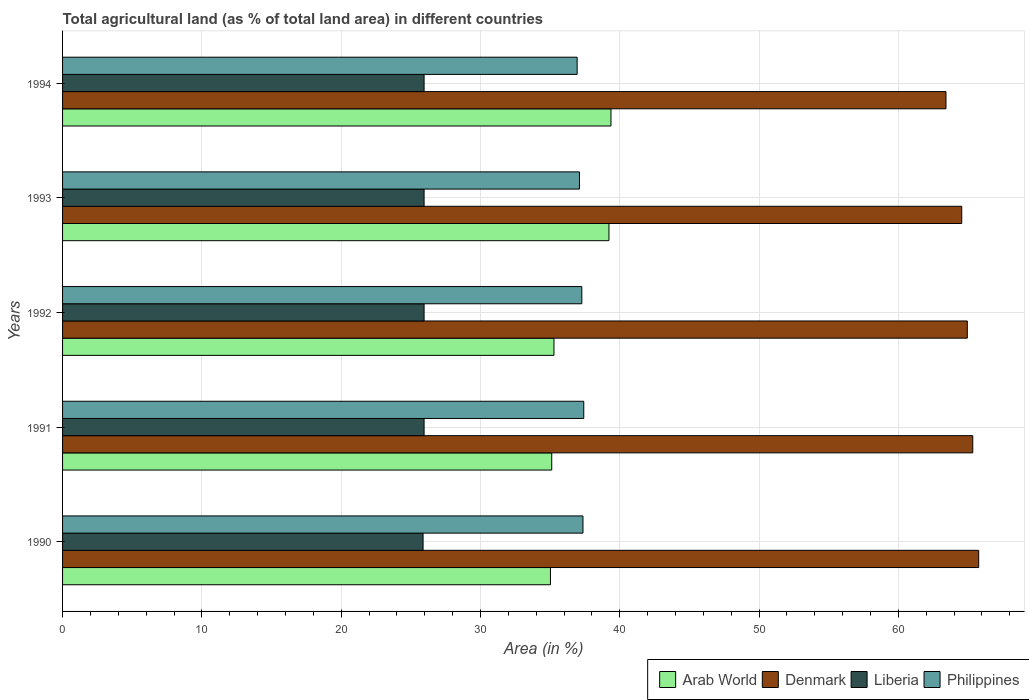How many different coloured bars are there?
Keep it short and to the point. 4. How many groups of bars are there?
Keep it short and to the point. 5. Are the number of bars per tick equal to the number of legend labels?
Offer a terse response. Yes. Are the number of bars on each tick of the Y-axis equal?
Your response must be concise. Yes. How many bars are there on the 3rd tick from the top?
Offer a terse response. 4. How many bars are there on the 4th tick from the bottom?
Ensure brevity in your answer.  4. What is the percentage of agricultural land in Arab World in 1993?
Provide a short and direct response. 39.23. Across all years, what is the maximum percentage of agricultural land in Liberia?
Provide a short and direct response. 25.96. Across all years, what is the minimum percentage of agricultural land in Philippines?
Provide a succinct answer. 36.94. In which year was the percentage of agricultural land in Denmark minimum?
Make the answer very short. 1994. What is the total percentage of agricultural land in Liberia in the graph?
Ensure brevity in your answer.  129.7. What is the difference between the percentage of agricultural land in Liberia in 1992 and that in 1994?
Your answer should be compact. 0. What is the difference between the percentage of agricultural land in Arab World in 1994 and the percentage of agricultural land in Liberia in 1991?
Provide a succinct answer. 13.42. What is the average percentage of agricultural land in Liberia per year?
Keep it short and to the point. 25.94. In the year 1993, what is the difference between the percentage of agricultural land in Arab World and percentage of agricultural land in Denmark?
Give a very brief answer. -25.33. In how many years, is the percentage of agricultural land in Denmark greater than 26 %?
Offer a terse response. 5. What is the ratio of the percentage of agricultural land in Denmark in 1993 to that in 1994?
Your response must be concise. 1.02. Is the percentage of agricultural land in Liberia in 1991 less than that in 1993?
Your response must be concise. No. What is the difference between the highest and the second highest percentage of agricultural land in Arab World?
Ensure brevity in your answer.  0.14. What is the difference between the highest and the lowest percentage of agricultural land in Liberia?
Your answer should be compact. 0.07. Is it the case that in every year, the sum of the percentage of agricultural land in Arab World and percentage of agricultural land in Liberia is greater than the sum of percentage of agricultural land in Philippines and percentage of agricultural land in Denmark?
Offer a terse response. No. What does the 1st bar from the top in 1992 represents?
Offer a very short reply. Philippines. What does the 2nd bar from the bottom in 1990 represents?
Your response must be concise. Denmark. How many bars are there?
Ensure brevity in your answer.  20. Are all the bars in the graph horizontal?
Offer a terse response. Yes. Does the graph contain any zero values?
Your answer should be very brief. No. Where does the legend appear in the graph?
Your answer should be compact. Bottom right. How are the legend labels stacked?
Make the answer very short. Horizontal. What is the title of the graph?
Provide a short and direct response. Total agricultural land (as % of total land area) in different countries. Does "Russian Federation" appear as one of the legend labels in the graph?
Keep it short and to the point. No. What is the label or title of the X-axis?
Provide a succinct answer. Area (in %). What is the Area (in %) of Arab World in 1990?
Offer a terse response. 35.03. What is the Area (in %) in Denmark in 1990?
Offer a very short reply. 65.77. What is the Area (in %) of Liberia in 1990?
Give a very brief answer. 25.88. What is the Area (in %) of Philippines in 1990?
Your answer should be very brief. 37.36. What is the Area (in %) of Arab World in 1991?
Your answer should be compact. 35.12. What is the Area (in %) in Denmark in 1991?
Provide a short and direct response. 65.35. What is the Area (in %) of Liberia in 1991?
Provide a succinct answer. 25.96. What is the Area (in %) of Philippines in 1991?
Offer a very short reply. 37.42. What is the Area (in %) of Arab World in 1992?
Provide a short and direct response. 35.28. What is the Area (in %) of Denmark in 1992?
Give a very brief answer. 64.95. What is the Area (in %) in Liberia in 1992?
Keep it short and to the point. 25.96. What is the Area (in %) of Philippines in 1992?
Make the answer very short. 37.28. What is the Area (in %) of Arab World in 1993?
Give a very brief answer. 39.23. What is the Area (in %) of Denmark in 1993?
Offer a very short reply. 64.55. What is the Area (in %) in Liberia in 1993?
Keep it short and to the point. 25.96. What is the Area (in %) of Philippines in 1993?
Keep it short and to the point. 37.11. What is the Area (in %) of Arab World in 1994?
Keep it short and to the point. 39.37. What is the Area (in %) of Denmark in 1994?
Provide a succinct answer. 63.42. What is the Area (in %) of Liberia in 1994?
Keep it short and to the point. 25.96. What is the Area (in %) of Philippines in 1994?
Keep it short and to the point. 36.94. Across all years, what is the maximum Area (in %) in Arab World?
Provide a succinct answer. 39.37. Across all years, what is the maximum Area (in %) of Denmark?
Provide a short and direct response. 65.77. Across all years, what is the maximum Area (in %) of Liberia?
Provide a succinct answer. 25.96. Across all years, what is the maximum Area (in %) of Philippines?
Make the answer very short. 37.42. Across all years, what is the minimum Area (in %) in Arab World?
Provide a short and direct response. 35.03. Across all years, what is the minimum Area (in %) of Denmark?
Offer a terse response. 63.42. Across all years, what is the minimum Area (in %) of Liberia?
Your answer should be very brief. 25.88. Across all years, what is the minimum Area (in %) in Philippines?
Give a very brief answer. 36.94. What is the total Area (in %) of Arab World in the graph?
Your answer should be compact. 184.02. What is the total Area (in %) in Denmark in the graph?
Offer a very short reply. 324.05. What is the total Area (in %) in Liberia in the graph?
Provide a succinct answer. 129.7. What is the total Area (in %) in Philippines in the graph?
Your answer should be very brief. 186.11. What is the difference between the Area (in %) in Arab World in 1990 and that in 1991?
Give a very brief answer. -0.09. What is the difference between the Area (in %) of Denmark in 1990 and that in 1991?
Make the answer very short. 0.42. What is the difference between the Area (in %) in Liberia in 1990 and that in 1991?
Provide a short and direct response. -0.07. What is the difference between the Area (in %) in Philippines in 1990 and that in 1991?
Ensure brevity in your answer.  -0.06. What is the difference between the Area (in %) in Arab World in 1990 and that in 1992?
Provide a succinct answer. -0.25. What is the difference between the Area (in %) in Denmark in 1990 and that in 1992?
Your answer should be compact. 0.82. What is the difference between the Area (in %) of Liberia in 1990 and that in 1992?
Make the answer very short. -0.07. What is the difference between the Area (in %) in Philippines in 1990 and that in 1992?
Provide a short and direct response. 0.08. What is the difference between the Area (in %) in Arab World in 1990 and that in 1993?
Keep it short and to the point. -4.2. What is the difference between the Area (in %) of Denmark in 1990 and that in 1993?
Give a very brief answer. 1.22. What is the difference between the Area (in %) in Liberia in 1990 and that in 1993?
Ensure brevity in your answer.  -0.07. What is the difference between the Area (in %) of Philippines in 1990 and that in 1993?
Give a very brief answer. 0.25. What is the difference between the Area (in %) in Arab World in 1990 and that in 1994?
Your response must be concise. -4.34. What is the difference between the Area (in %) of Denmark in 1990 and that in 1994?
Provide a succinct answer. 2.35. What is the difference between the Area (in %) of Liberia in 1990 and that in 1994?
Offer a terse response. -0.07. What is the difference between the Area (in %) of Philippines in 1990 and that in 1994?
Offer a very short reply. 0.42. What is the difference between the Area (in %) of Arab World in 1991 and that in 1992?
Ensure brevity in your answer.  -0.16. What is the difference between the Area (in %) in Denmark in 1991 and that in 1992?
Make the answer very short. 0.39. What is the difference between the Area (in %) in Philippines in 1991 and that in 1992?
Ensure brevity in your answer.  0.14. What is the difference between the Area (in %) in Arab World in 1991 and that in 1993?
Keep it short and to the point. -4.11. What is the difference between the Area (in %) in Denmark in 1991 and that in 1993?
Ensure brevity in your answer.  0.79. What is the difference between the Area (in %) in Liberia in 1991 and that in 1993?
Offer a very short reply. 0. What is the difference between the Area (in %) in Philippines in 1991 and that in 1993?
Your answer should be compact. 0.31. What is the difference between the Area (in %) in Arab World in 1991 and that in 1994?
Keep it short and to the point. -4.25. What is the difference between the Area (in %) in Denmark in 1991 and that in 1994?
Your answer should be compact. 1.92. What is the difference between the Area (in %) in Philippines in 1991 and that in 1994?
Provide a short and direct response. 0.48. What is the difference between the Area (in %) in Arab World in 1992 and that in 1993?
Keep it short and to the point. -3.95. What is the difference between the Area (in %) in Denmark in 1992 and that in 1993?
Your response must be concise. 0.4. What is the difference between the Area (in %) in Liberia in 1992 and that in 1993?
Keep it short and to the point. 0. What is the difference between the Area (in %) in Philippines in 1992 and that in 1993?
Make the answer very short. 0.17. What is the difference between the Area (in %) in Arab World in 1992 and that in 1994?
Provide a short and direct response. -4.09. What is the difference between the Area (in %) of Denmark in 1992 and that in 1994?
Provide a succinct answer. 1.53. What is the difference between the Area (in %) of Liberia in 1992 and that in 1994?
Provide a short and direct response. 0. What is the difference between the Area (in %) of Philippines in 1992 and that in 1994?
Offer a very short reply. 0.34. What is the difference between the Area (in %) of Arab World in 1993 and that in 1994?
Provide a succinct answer. -0.14. What is the difference between the Area (in %) of Denmark in 1993 and that in 1994?
Make the answer very short. 1.13. What is the difference between the Area (in %) in Philippines in 1993 and that in 1994?
Provide a short and direct response. 0.17. What is the difference between the Area (in %) of Arab World in 1990 and the Area (in %) of Denmark in 1991?
Ensure brevity in your answer.  -30.32. What is the difference between the Area (in %) in Arab World in 1990 and the Area (in %) in Liberia in 1991?
Make the answer very short. 9.07. What is the difference between the Area (in %) of Arab World in 1990 and the Area (in %) of Philippines in 1991?
Make the answer very short. -2.39. What is the difference between the Area (in %) in Denmark in 1990 and the Area (in %) in Liberia in 1991?
Your answer should be compact. 39.82. What is the difference between the Area (in %) in Denmark in 1990 and the Area (in %) in Philippines in 1991?
Your answer should be very brief. 28.35. What is the difference between the Area (in %) of Liberia in 1990 and the Area (in %) of Philippines in 1991?
Your response must be concise. -11.54. What is the difference between the Area (in %) of Arab World in 1990 and the Area (in %) of Denmark in 1992?
Give a very brief answer. -29.93. What is the difference between the Area (in %) in Arab World in 1990 and the Area (in %) in Liberia in 1992?
Your response must be concise. 9.07. What is the difference between the Area (in %) of Arab World in 1990 and the Area (in %) of Philippines in 1992?
Provide a succinct answer. -2.25. What is the difference between the Area (in %) in Denmark in 1990 and the Area (in %) in Liberia in 1992?
Ensure brevity in your answer.  39.82. What is the difference between the Area (in %) in Denmark in 1990 and the Area (in %) in Philippines in 1992?
Your response must be concise. 28.49. What is the difference between the Area (in %) of Liberia in 1990 and the Area (in %) of Philippines in 1992?
Your answer should be compact. -11.39. What is the difference between the Area (in %) of Arab World in 1990 and the Area (in %) of Denmark in 1993?
Provide a succinct answer. -29.53. What is the difference between the Area (in %) in Arab World in 1990 and the Area (in %) in Liberia in 1993?
Ensure brevity in your answer.  9.07. What is the difference between the Area (in %) in Arab World in 1990 and the Area (in %) in Philippines in 1993?
Your answer should be compact. -2.08. What is the difference between the Area (in %) in Denmark in 1990 and the Area (in %) in Liberia in 1993?
Your answer should be compact. 39.82. What is the difference between the Area (in %) in Denmark in 1990 and the Area (in %) in Philippines in 1993?
Provide a short and direct response. 28.66. What is the difference between the Area (in %) of Liberia in 1990 and the Area (in %) of Philippines in 1993?
Make the answer very short. -11.23. What is the difference between the Area (in %) of Arab World in 1990 and the Area (in %) of Denmark in 1994?
Provide a succinct answer. -28.39. What is the difference between the Area (in %) in Arab World in 1990 and the Area (in %) in Liberia in 1994?
Make the answer very short. 9.07. What is the difference between the Area (in %) in Arab World in 1990 and the Area (in %) in Philippines in 1994?
Give a very brief answer. -1.91. What is the difference between the Area (in %) of Denmark in 1990 and the Area (in %) of Liberia in 1994?
Make the answer very short. 39.82. What is the difference between the Area (in %) in Denmark in 1990 and the Area (in %) in Philippines in 1994?
Provide a short and direct response. 28.83. What is the difference between the Area (in %) in Liberia in 1990 and the Area (in %) in Philippines in 1994?
Keep it short and to the point. -11.06. What is the difference between the Area (in %) in Arab World in 1991 and the Area (in %) in Denmark in 1992?
Make the answer very short. -29.84. What is the difference between the Area (in %) in Arab World in 1991 and the Area (in %) in Liberia in 1992?
Provide a succinct answer. 9.16. What is the difference between the Area (in %) of Arab World in 1991 and the Area (in %) of Philippines in 1992?
Your answer should be very brief. -2.16. What is the difference between the Area (in %) in Denmark in 1991 and the Area (in %) in Liberia in 1992?
Make the answer very short. 39.39. What is the difference between the Area (in %) of Denmark in 1991 and the Area (in %) of Philippines in 1992?
Your answer should be compact. 28.07. What is the difference between the Area (in %) of Liberia in 1991 and the Area (in %) of Philippines in 1992?
Ensure brevity in your answer.  -11.32. What is the difference between the Area (in %) of Arab World in 1991 and the Area (in %) of Denmark in 1993?
Provide a short and direct response. -29.44. What is the difference between the Area (in %) in Arab World in 1991 and the Area (in %) in Liberia in 1993?
Your response must be concise. 9.16. What is the difference between the Area (in %) in Arab World in 1991 and the Area (in %) in Philippines in 1993?
Keep it short and to the point. -1.99. What is the difference between the Area (in %) of Denmark in 1991 and the Area (in %) of Liberia in 1993?
Keep it short and to the point. 39.39. What is the difference between the Area (in %) in Denmark in 1991 and the Area (in %) in Philippines in 1993?
Your answer should be compact. 28.24. What is the difference between the Area (in %) in Liberia in 1991 and the Area (in %) in Philippines in 1993?
Make the answer very short. -11.15. What is the difference between the Area (in %) in Arab World in 1991 and the Area (in %) in Denmark in 1994?
Keep it short and to the point. -28.3. What is the difference between the Area (in %) of Arab World in 1991 and the Area (in %) of Liberia in 1994?
Offer a terse response. 9.16. What is the difference between the Area (in %) in Arab World in 1991 and the Area (in %) in Philippines in 1994?
Offer a terse response. -1.82. What is the difference between the Area (in %) of Denmark in 1991 and the Area (in %) of Liberia in 1994?
Provide a succinct answer. 39.39. What is the difference between the Area (in %) of Denmark in 1991 and the Area (in %) of Philippines in 1994?
Give a very brief answer. 28.4. What is the difference between the Area (in %) in Liberia in 1991 and the Area (in %) in Philippines in 1994?
Keep it short and to the point. -10.99. What is the difference between the Area (in %) of Arab World in 1992 and the Area (in %) of Denmark in 1993?
Keep it short and to the point. -29.27. What is the difference between the Area (in %) in Arab World in 1992 and the Area (in %) in Liberia in 1993?
Keep it short and to the point. 9.32. What is the difference between the Area (in %) of Arab World in 1992 and the Area (in %) of Philippines in 1993?
Ensure brevity in your answer.  -1.83. What is the difference between the Area (in %) in Denmark in 1992 and the Area (in %) in Liberia in 1993?
Keep it short and to the point. 39. What is the difference between the Area (in %) of Denmark in 1992 and the Area (in %) of Philippines in 1993?
Offer a very short reply. 27.84. What is the difference between the Area (in %) of Liberia in 1992 and the Area (in %) of Philippines in 1993?
Your answer should be compact. -11.15. What is the difference between the Area (in %) of Arab World in 1992 and the Area (in %) of Denmark in 1994?
Provide a succinct answer. -28.14. What is the difference between the Area (in %) in Arab World in 1992 and the Area (in %) in Liberia in 1994?
Provide a succinct answer. 9.32. What is the difference between the Area (in %) of Arab World in 1992 and the Area (in %) of Philippines in 1994?
Provide a short and direct response. -1.66. What is the difference between the Area (in %) in Denmark in 1992 and the Area (in %) in Liberia in 1994?
Your answer should be compact. 39. What is the difference between the Area (in %) of Denmark in 1992 and the Area (in %) of Philippines in 1994?
Give a very brief answer. 28.01. What is the difference between the Area (in %) of Liberia in 1992 and the Area (in %) of Philippines in 1994?
Give a very brief answer. -10.99. What is the difference between the Area (in %) of Arab World in 1993 and the Area (in %) of Denmark in 1994?
Keep it short and to the point. -24.2. What is the difference between the Area (in %) in Arab World in 1993 and the Area (in %) in Liberia in 1994?
Ensure brevity in your answer.  13.27. What is the difference between the Area (in %) of Arab World in 1993 and the Area (in %) of Philippines in 1994?
Offer a terse response. 2.28. What is the difference between the Area (in %) of Denmark in 1993 and the Area (in %) of Liberia in 1994?
Ensure brevity in your answer.  38.6. What is the difference between the Area (in %) in Denmark in 1993 and the Area (in %) in Philippines in 1994?
Ensure brevity in your answer.  27.61. What is the difference between the Area (in %) of Liberia in 1993 and the Area (in %) of Philippines in 1994?
Offer a very short reply. -10.99. What is the average Area (in %) of Arab World per year?
Ensure brevity in your answer.  36.8. What is the average Area (in %) in Denmark per year?
Offer a very short reply. 64.81. What is the average Area (in %) in Liberia per year?
Make the answer very short. 25.94. What is the average Area (in %) of Philippines per year?
Ensure brevity in your answer.  37.22. In the year 1990, what is the difference between the Area (in %) in Arab World and Area (in %) in Denmark?
Keep it short and to the point. -30.74. In the year 1990, what is the difference between the Area (in %) in Arab World and Area (in %) in Liberia?
Provide a short and direct response. 9.14. In the year 1990, what is the difference between the Area (in %) of Arab World and Area (in %) of Philippines?
Ensure brevity in your answer.  -2.33. In the year 1990, what is the difference between the Area (in %) in Denmark and Area (in %) in Liberia?
Ensure brevity in your answer.  39.89. In the year 1990, what is the difference between the Area (in %) in Denmark and Area (in %) in Philippines?
Give a very brief answer. 28.41. In the year 1990, what is the difference between the Area (in %) of Liberia and Area (in %) of Philippines?
Give a very brief answer. -11.48. In the year 1991, what is the difference between the Area (in %) of Arab World and Area (in %) of Denmark?
Ensure brevity in your answer.  -30.23. In the year 1991, what is the difference between the Area (in %) in Arab World and Area (in %) in Liberia?
Ensure brevity in your answer.  9.16. In the year 1991, what is the difference between the Area (in %) in Arab World and Area (in %) in Philippines?
Keep it short and to the point. -2.3. In the year 1991, what is the difference between the Area (in %) in Denmark and Area (in %) in Liberia?
Your answer should be compact. 39.39. In the year 1991, what is the difference between the Area (in %) of Denmark and Area (in %) of Philippines?
Provide a short and direct response. 27.93. In the year 1991, what is the difference between the Area (in %) in Liberia and Area (in %) in Philippines?
Ensure brevity in your answer.  -11.46. In the year 1992, what is the difference between the Area (in %) of Arab World and Area (in %) of Denmark?
Your answer should be compact. -29.68. In the year 1992, what is the difference between the Area (in %) in Arab World and Area (in %) in Liberia?
Ensure brevity in your answer.  9.32. In the year 1992, what is the difference between the Area (in %) in Arab World and Area (in %) in Philippines?
Make the answer very short. -2. In the year 1992, what is the difference between the Area (in %) of Denmark and Area (in %) of Liberia?
Provide a short and direct response. 39. In the year 1992, what is the difference between the Area (in %) of Denmark and Area (in %) of Philippines?
Your answer should be very brief. 27.68. In the year 1992, what is the difference between the Area (in %) in Liberia and Area (in %) in Philippines?
Provide a short and direct response. -11.32. In the year 1993, what is the difference between the Area (in %) of Arab World and Area (in %) of Denmark?
Offer a terse response. -25.33. In the year 1993, what is the difference between the Area (in %) in Arab World and Area (in %) in Liberia?
Offer a very short reply. 13.27. In the year 1993, what is the difference between the Area (in %) of Arab World and Area (in %) of Philippines?
Provide a short and direct response. 2.12. In the year 1993, what is the difference between the Area (in %) in Denmark and Area (in %) in Liberia?
Ensure brevity in your answer.  38.6. In the year 1993, what is the difference between the Area (in %) of Denmark and Area (in %) of Philippines?
Offer a very short reply. 27.44. In the year 1993, what is the difference between the Area (in %) in Liberia and Area (in %) in Philippines?
Your response must be concise. -11.15. In the year 1994, what is the difference between the Area (in %) of Arab World and Area (in %) of Denmark?
Make the answer very short. -24.05. In the year 1994, what is the difference between the Area (in %) of Arab World and Area (in %) of Liberia?
Keep it short and to the point. 13.42. In the year 1994, what is the difference between the Area (in %) of Arab World and Area (in %) of Philippines?
Your answer should be compact. 2.43. In the year 1994, what is the difference between the Area (in %) in Denmark and Area (in %) in Liberia?
Your answer should be compact. 37.47. In the year 1994, what is the difference between the Area (in %) in Denmark and Area (in %) in Philippines?
Give a very brief answer. 26.48. In the year 1994, what is the difference between the Area (in %) in Liberia and Area (in %) in Philippines?
Your response must be concise. -10.99. What is the ratio of the Area (in %) of Denmark in 1990 to that in 1991?
Offer a very short reply. 1.01. What is the ratio of the Area (in %) of Liberia in 1990 to that in 1991?
Your response must be concise. 1. What is the ratio of the Area (in %) of Denmark in 1990 to that in 1992?
Give a very brief answer. 1.01. What is the ratio of the Area (in %) in Philippines in 1990 to that in 1992?
Offer a very short reply. 1. What is the ratio of the Area (in %) of Arab World in 1990 to that in 1993?
Your answer should be compact. 0.89. What is the ratio of the Area (in %) in Denmark in 1990 to that in 1993?
Provide a succinct answer. 1.02. What is the ratio of the Area (in %) in Philippines in 1990 to that in 1993?
Your response must be concise. 1.01. What is the ratio of the Area (in %) in Arab World in 1990 to that in 1994?
Provide a succinct answer. 0.89. What is the ratio of the Area (in %) in Liberia in 1990 to that in 1994?
Your answer should be compact. 1. What is the ratio of the Area (in %) in Philippines in 1990 to that in 1994?
Provide a succinct answer. 1.01. What is the ratio of the Area (in %) in Denmark in 1991 to that in 1992?
Give a very brief answer. 1.01. What is the ratio of the Area (in %) of Arab World in 1991 to that in 1993?
Your answer should be very brief. 0.9. What is the ratio of the Area (in %) in Denmark in 1991 to that in 1993?
Offer a terse response. 1.01. What is the ratio of the Area (in %) of Liberia in 1991 to that in 1993?
Make the answer very short. 1. What is the ratio of the Area (in %) of Philippines in 1991 to that in 1993?
Give a very brief answer. 1.01. What is the ratio of the Area (in %) in Arab World in 1991 to that in 1994?
Provide a short and direct response. 0.89. What is the ratio of the Area (in %) of Denmark in 1991 to that in 1994?
Your answer should be compact. 1.03. What is the ratio of the Area (in %) of Liberia in 1991 to that in 1994?
Keep it short and to the point. 1. What is the ratio of the Area (in %) of Philippines in 1991 to that in 1994?
Provide a short and direct response. 1.01. What is the ratio of the Area (in %) in Arab World in 1992 to that in 1993?
Offer a terse response. 0.9. What is the ratio of the Area (in %) in Philippines in 1992 to that in 1993?
Make the answer very short. 1. What is the ratio of the Area (in %) in Arab World in 1992 to that in 1994?
Provide a short and direct response. 0.9. What is the ratio of the Area (in %) of Denmark in 1992 to that in 1994?
Make the answer very short. 1.02. What is the ratio of the Area (in %) of Philippines in 1992 to that in 1994?
Provide a succinct answer. 1.01. What is the ratio of the Area (in %) in Denmark in 1993 to that in 1994?
Your response must be concise. 1.02. What is the ratio of the Area (in %) of Liberia in 1993 to that in 1994?
Provide a succinct answer. 1. What is the ratio of the Area (in %) in Philippines in 1993 to that in 1994?
Make the answer very short. 1. What is the difference between the highest and the second highest Area (in %) of Arab World?
Make the answer very short. 0.14. What is the difference between the highest and the second highest Area (in %) of Denmark?
Offer a terse response. 0.42. What is the difference between the highest and the second highest Area (in %) in Philippines?
Provide a short and direct response. 0.06. What is the difference between the highest and the lowest Area (in %) of Arab World?
Offer a terse response. 4.34. What is the difference between the highest and the lowest Area (in %) of Denmark?
Provide a succinct answer. 2.35. What is the difference between the highest and the lowest Area (in %) of Liberia?
Keep it short and to the point. 0.07. What is the difference between the highest and the lowest Area (in %) of Philippines?
Offer a very short reply. 0.48. 